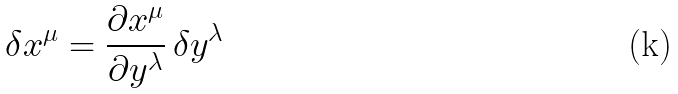<formula> <loc_0><loc_0><loc_500><loc_500>\delta x ^ { \mu } = \frac { \partial x ^ { \mu } } { \partial y ^ { \lambda } } \, \delta y ^ { \lambda }</formula> 